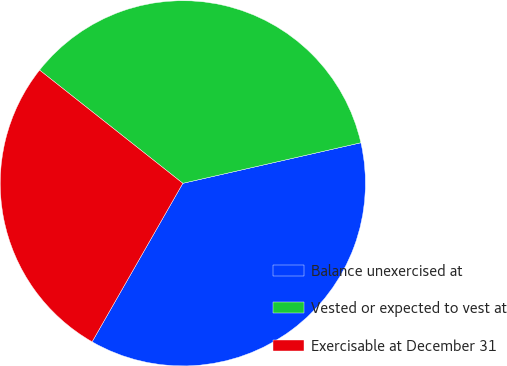Convert chart. <chart><loc_0><loc_0><loc_500><loc_500><pie_chart><fcel>Balance unexercised at<fcel>Vested or expected to vest at<fcel>Exercisable at December 31<nl><fcel>36.84%<fcel>35.79%<fcel>27.37%<nl></chart> 